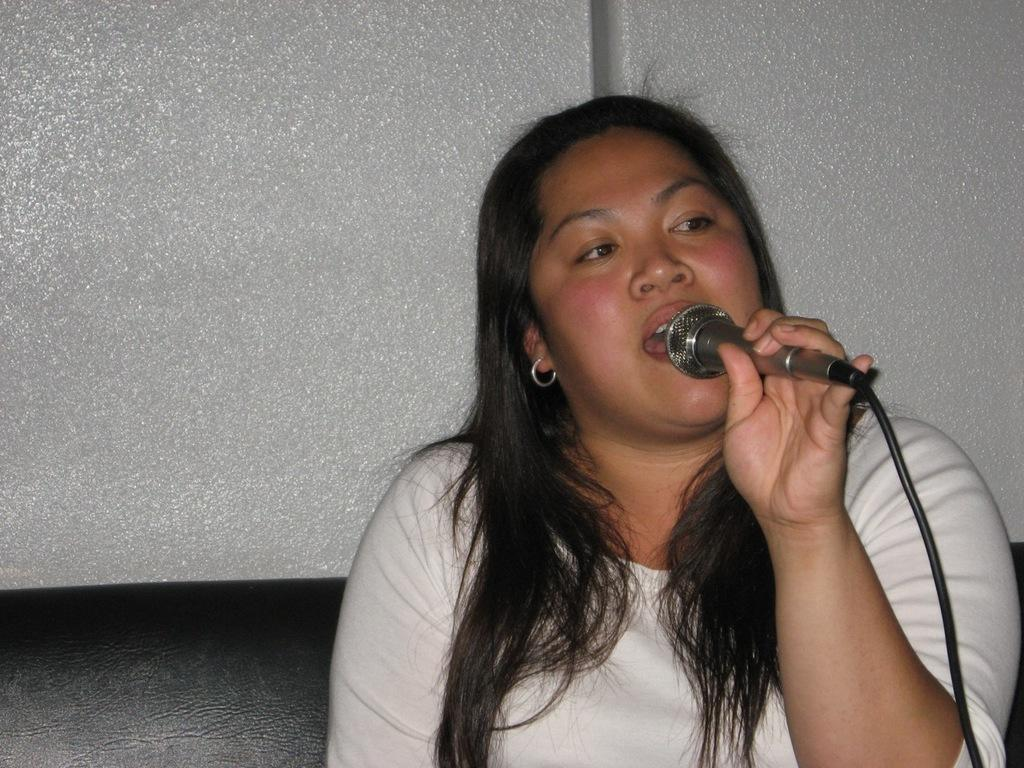Who is present in the image? There is a woman in the image. What is the woman doing in the image? The woman is sitting on a sofa and holding a mic. What can be seen in the background of the image? There is a wall in the background of the image. What type of pizzas can be seen on the wall in the image? There are no pizzas present in the image; the background only shows a wall. 